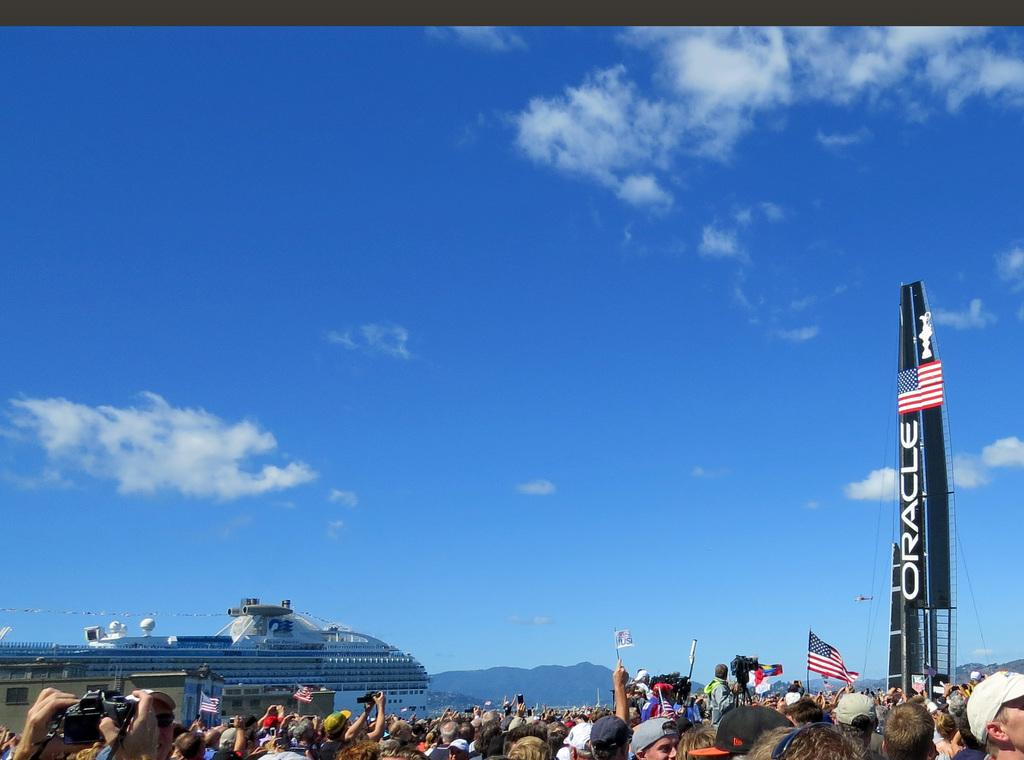How many people can be seen in the image? There are a few people in the image. What is the main object in the image? There is a ship in the image. What else can be seen in the image besides the ship? There are flags, a tower with text and images, and the sky visible in the image. What is the condition of the sky in the image? The sky is visible in the image, and clouds are present. What type of digestion can be observed in the image? There is no digestion present in the image; it features a ship, people, flags, a tower, and the sky. What color are the trousers worn by the people in the image? There is no information about the color of the people's trousers in the image. 